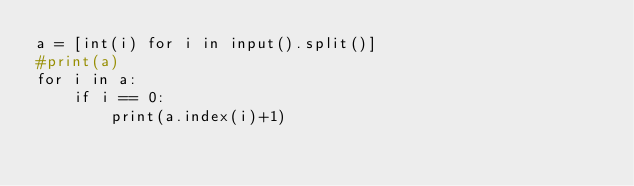Convert code to text. <code><loc_0><loc_0><loc_500><loc_500><_Python_>a = [int(i) for i in input().split()]
#print(a)
for i in a:
    if i == 0:
        print(a.index(i)+1)</code> 